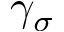<formula> <loc_0><loc_0><loc_500><loc_500>\gamma _ { \sigma }</formula> 